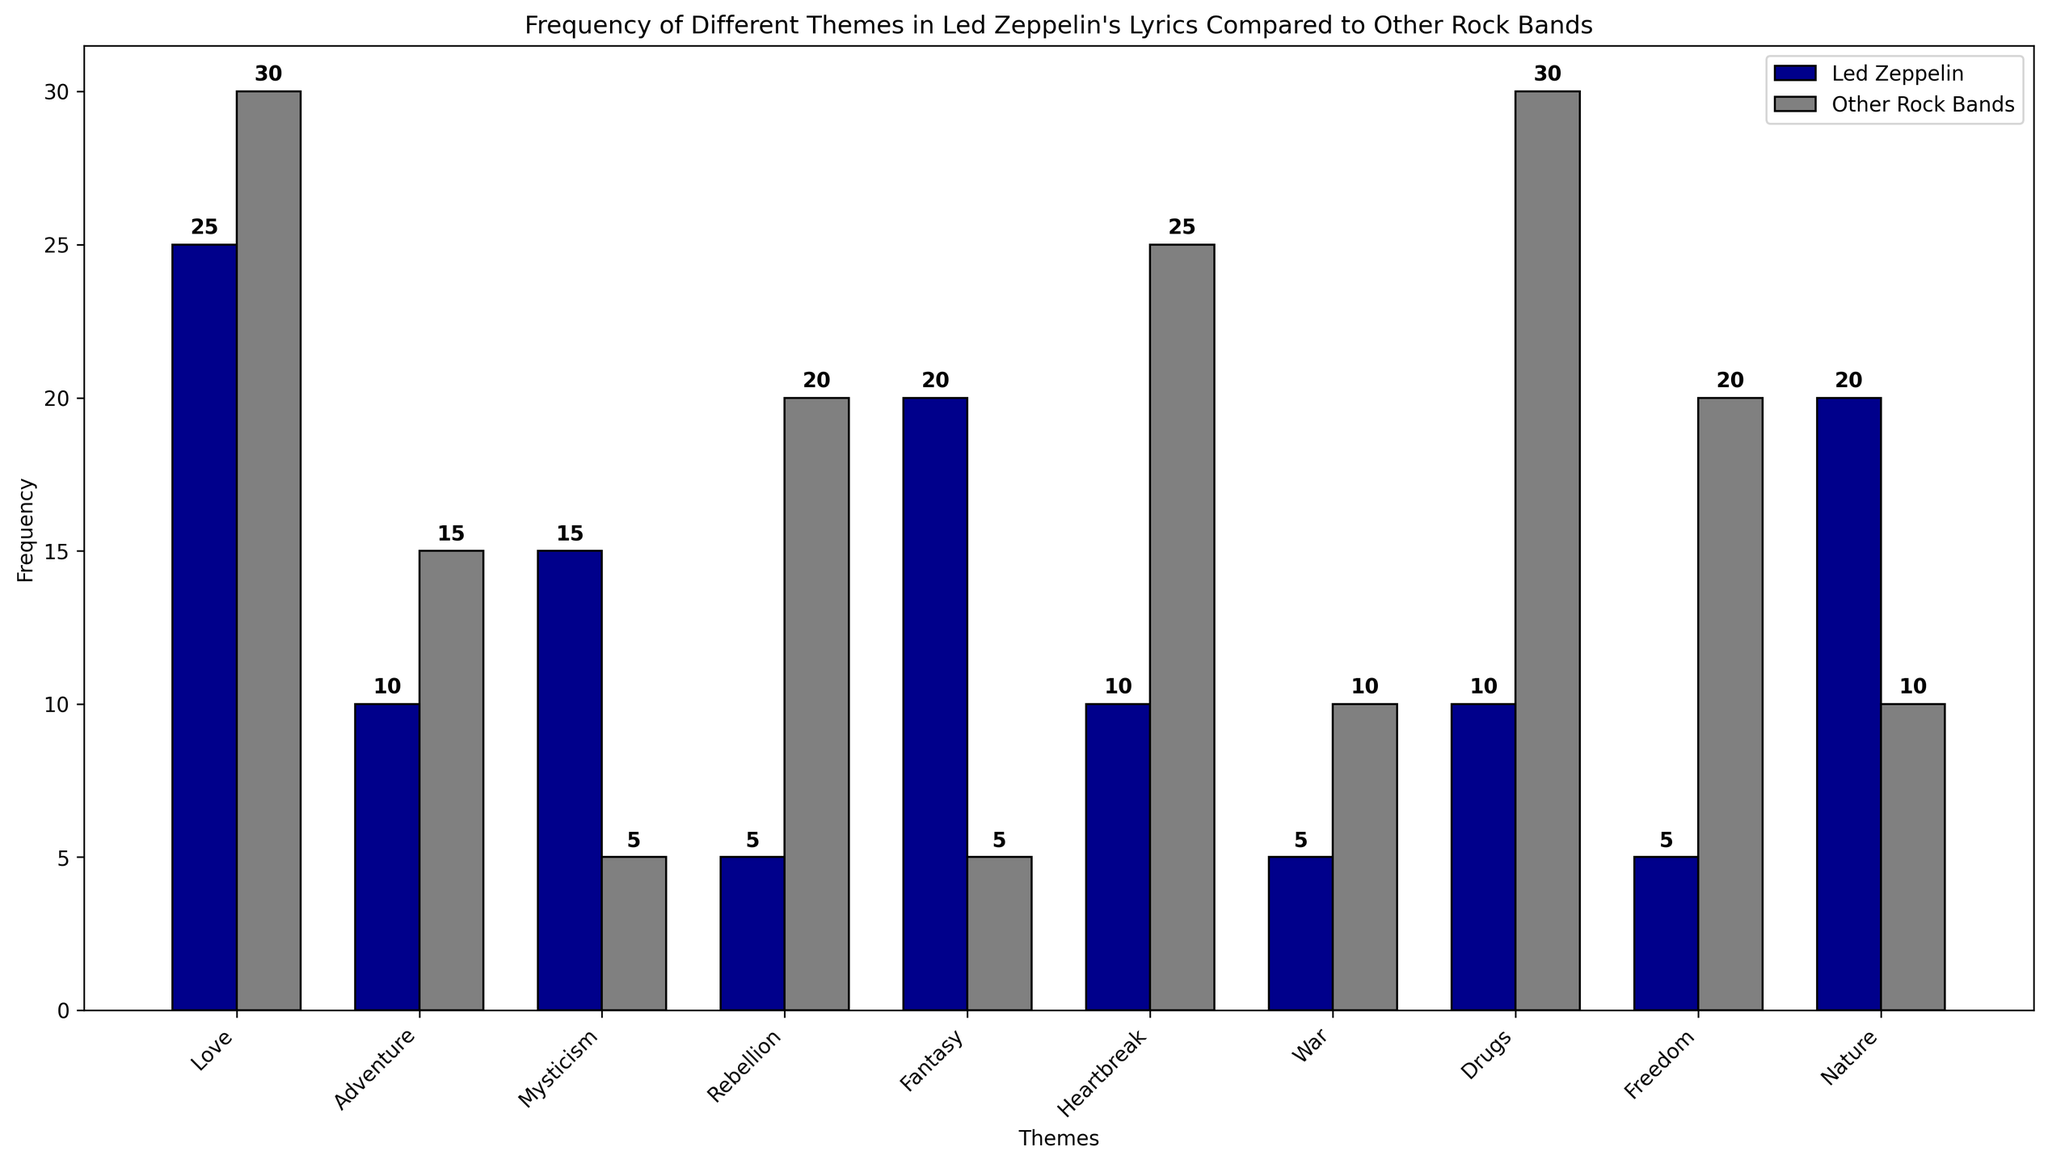What's the most common theme in Led Zeppelin's lyrics based on the chart? The theme with the tallest bar for Led Zeppelin will be the most common. The bar for "Love" has a height of 25, which is greater than any other bar for Led Zeppelin themes.
Answer: Love Which theme shows the biggest contrast between Led Zeppelin and other rock bands? Look for the theme where the difference between the heights of the two bars (one for Led Zeppelin and the other for other rock bands) is the greatest. "Drugs" has a frequency of 10 for Led Zeppelin and 30 for other rock bands, showing a difference of 20.
Answer: Drugs Which theme is more frequently mentioned by Led Zeppelin compared to other rock bands? Find themes where Led Zeppelin's bar is taller than the bar for other rock bands. Examples include "Mysticism" (Led Zeppelin 15, Other Rock Bands 5) and "Fantasy" (Led Zeppelin 20, Other Rock Bands 5).
Answer: Mysticism, Fantasy What's the combined frequency of the "Nature" theme for both Led Zeppelin and other rock bands? Add the heights of both bars for "Nature". Led Zeppelin has a frequency of 20 and other rock bands 10. Hence, 20 + 10 = 30.
Answer: 30 In how many themes does Led Zeppelin have a lower frequency than other rock bands? Count the number of themes where Led Zeppelin's bar is shorter than the bar for other rock bands. The themes are "Love", "Adventure", "Rebellion", "Heartbreak", "War", "Drugs", and "Freedom", making a total of 7 themes.
Answer: 7 Which themes have the same frequency for both Led Zeppelin and other rock bands? Compare the heights of the bars for each theme. None of the themes have bars with the same height for Led Zeppelin and other rock bands.
Answer: None What's the average frequency of the "Love" theme across Led Zeppelin and other rock bands? Find the average by summing the frequencies of the "Love" theme for both and dividing by 2. So, (25 + 30) / 2 = 27.5.
Answer: 27.5 Which theme does Led Zeppelin discuss more than "War" but less than "Fantasy"? Find a theme with a frequency for Led Zeppelin between 5 ("War") and 20 ("Fantasy"). "Nature" has a frequency of 20, equal to "Fantasy", so "Mysticism" with a frequency of 15 fits the criteria.
Answer: Mysticism Which theme related to rebellion or freedom is less frequently mentioned by Led Zeppelin? Compare the frequencies of "Rebellion" and "Freedom". Both themes have the same frequency of 5 for Led Zeppelin.
Answer: Rebellion, Freedom 